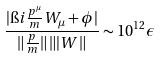<formula> <loc_0><loc_0><loc_500><loc_500>\frac { | \i i \frac { p ^ { \mu } } { m } W _ { \mu } + \phi | } { \| \frac { p } { m } \| \, \| | W \| } \sim 1 0 ^ { 1 2 } \epsilon</formula> 